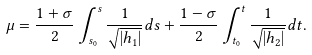Convert formula to latex. <formula><loc_0><loc_0><loc_500><loc_500>\mu = \frac { 1 + \sigma } { 2 } \int _ { s _ { 0 } } ^ { s } \frac { 1 } { \sqrt { | h _ { 1 } | } } d s + \frac { 1 - \sigma } { 2 } \int _ { t _ { 0 } } ^ { t } \frac { 1 } { \sqrt { | h _ { 2 } | } } d t .</formula> 